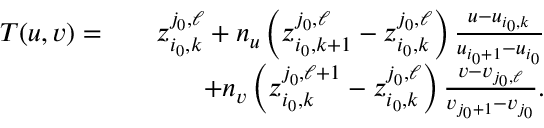<formula> <loc_0><loc_0><loc_500><loc_500>\begin{array} { r l r } { T ( u , v ) = } & { z _ { i _ { 0 } , k } ^ { j _ { 0 } , \ell } + n _ { u } \left ( z _ { i _ { 0 } , k + 1 } ^ { j _ { 0 } , \ell } - z _ { i _ { 0 } , k } ^ { j _ { 0 } , \ell } \right ) \frac { u - u _ { i _ { 0 } , k } } { u _ { i _ { 0 } + 1 } - u _ { i _ { 0 } } } } \\ & { + n _ { v } \left ( z _ { i _ { 0 } , k } ^ { j _ { 0 } , \ell + 1 } - z _ { i _ { 0 } , k } ^ { j _ { 0 } , \ell } \right ) \frac { v - v _ { j _ { 0 } , \ell } } { v _ { j _ { 0 } + 1 } - v _ { j _ { 0 } } } . } \end{array}</formula> 